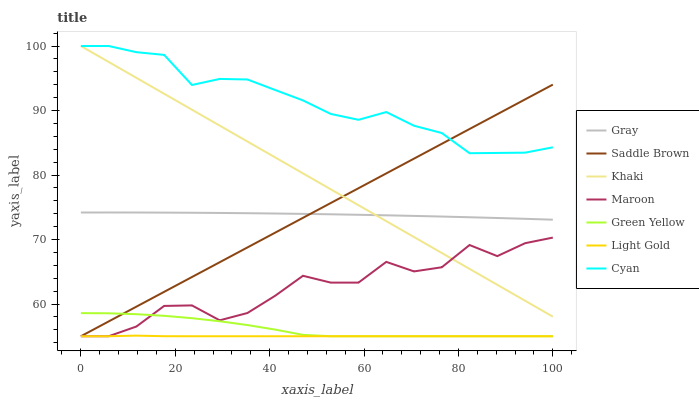Does Light Gold have the minimum area under the curve?
Answer yes or no. Yes. Does Cyan have the maximum area under the curve?
Answer yes or no. Yes. Does Khaki have the minimum area under the curve?
Answer yes or no. No. Does Khaki have the maximum area under the curve?
Answer yes or no. No. Is Saddle Brown the smoothest?
Answer yes or no. Yes. Is Maroon the roughest?
Answer yes or no. Yes. Is Khaki the smoothest?
Answer yes or no. No. Is Khaki the roughest?
Answer yes or no. No. Does Khaki have the lowest value?
Answer yes or no. No. Does Cyan have the highest value?
Answer yes or no. Yes. Does Maroon have the highest value?
Answer yes or no. No. Is Light Gold less than Khaki?
Answer yes or no. Yes. Is Khaki greater than Light Gold?
Answer yes or no. Yes. Does Saddle Brown intersect Green Yellow?
Answer yes or no. Yes. Is Saddle Brown less than Green Yellow?
Answer yes or no. No. Is Saddle Brown greater than Green Yellow?
Answer yes or no. No. Does Light Gold intersect Khaki?
Answer yes or no. No. 